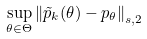<formula> <loc_0><loc_0><loc_500><loc_500>\sup _ { \theta \in \Theta } \left \| \tilde { p } _ { k } ( \theta ) - p _ { \theta } \right \| _ { s , 2 }</formula> 